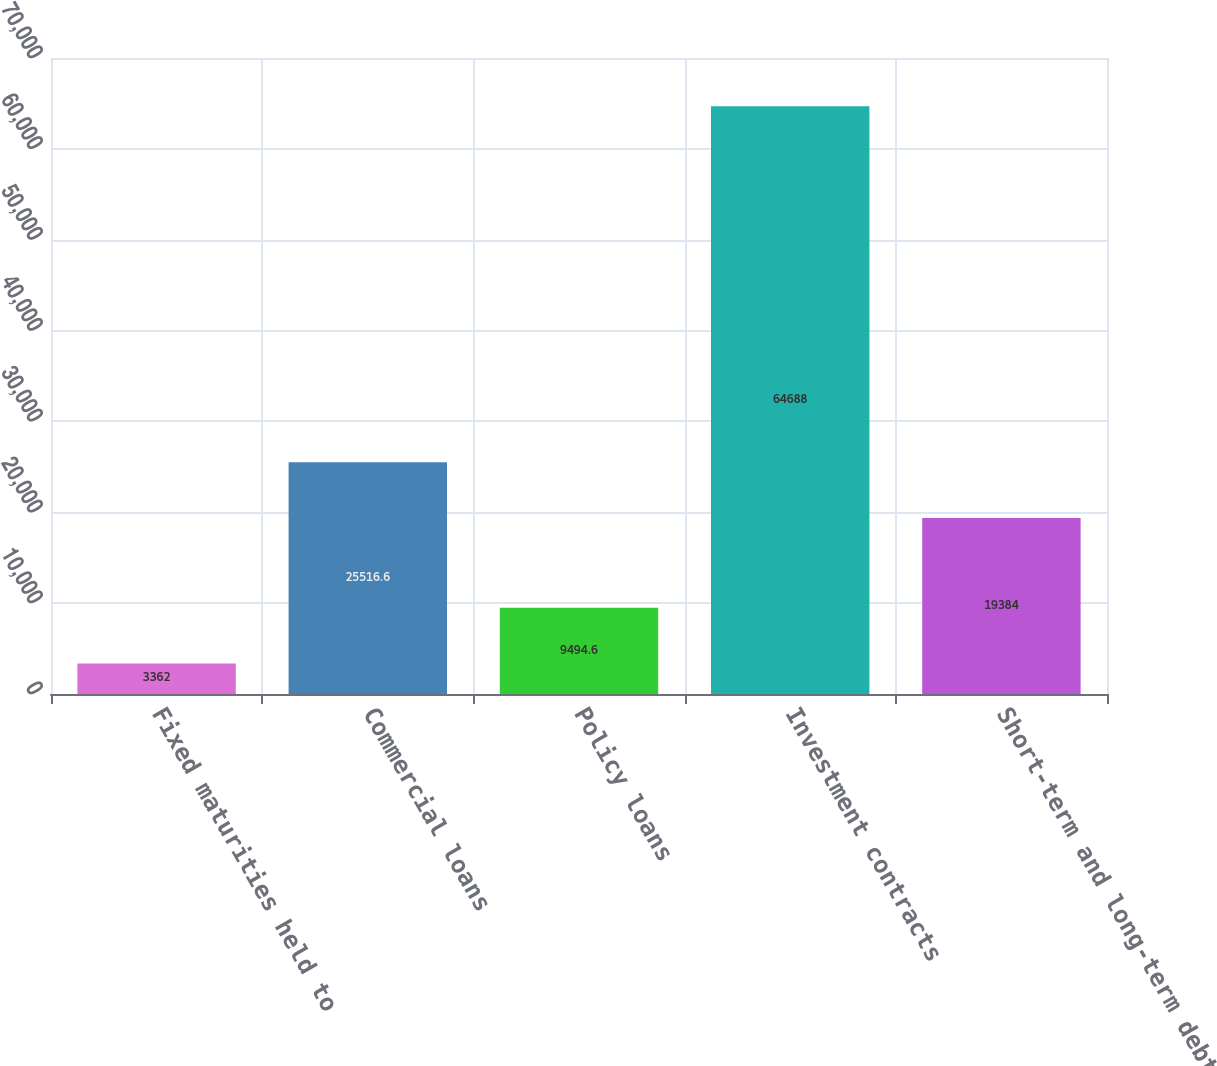Convert chart. <chart><loc_0><loc_0><loc_500><loc_500><bar_chart><fcel>Fixed maturities held to<fcel>Commercial loans<fcel>Policy loans<fcel>Investment contracts<fcel>Short-term and long-term debt<nl><fcel>3362<fcel>25516.6<fcel>9494.6<fcel>64688<fcel>19384<nl></chart> 